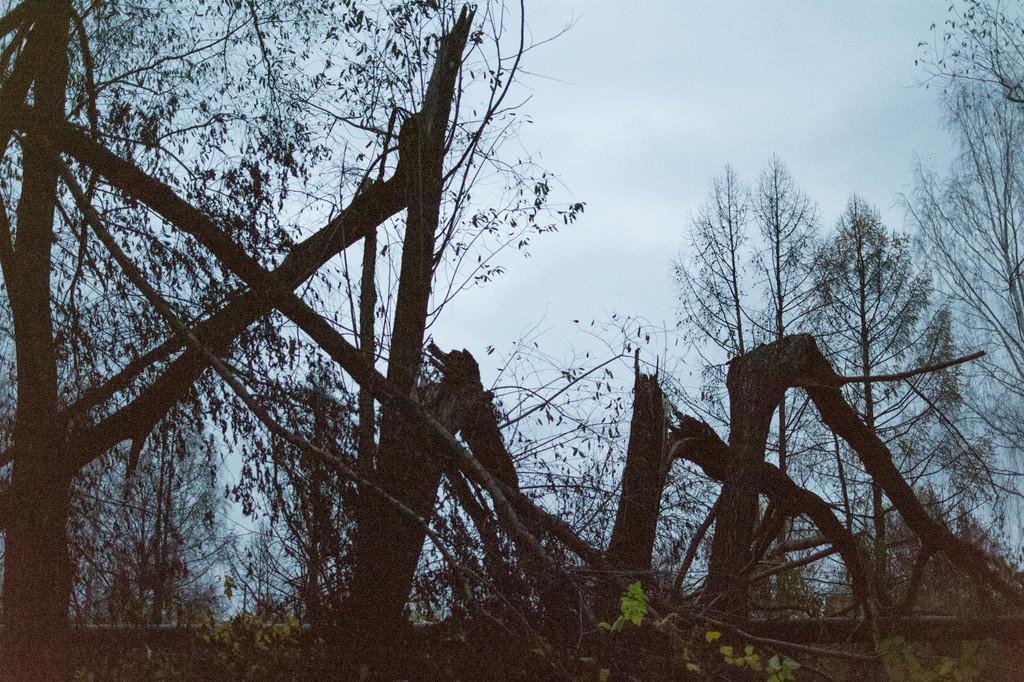Can you describe this image briefly? In the foreground of the picture there are trees the trees, the trees are chopped. Sky is cloudy. 